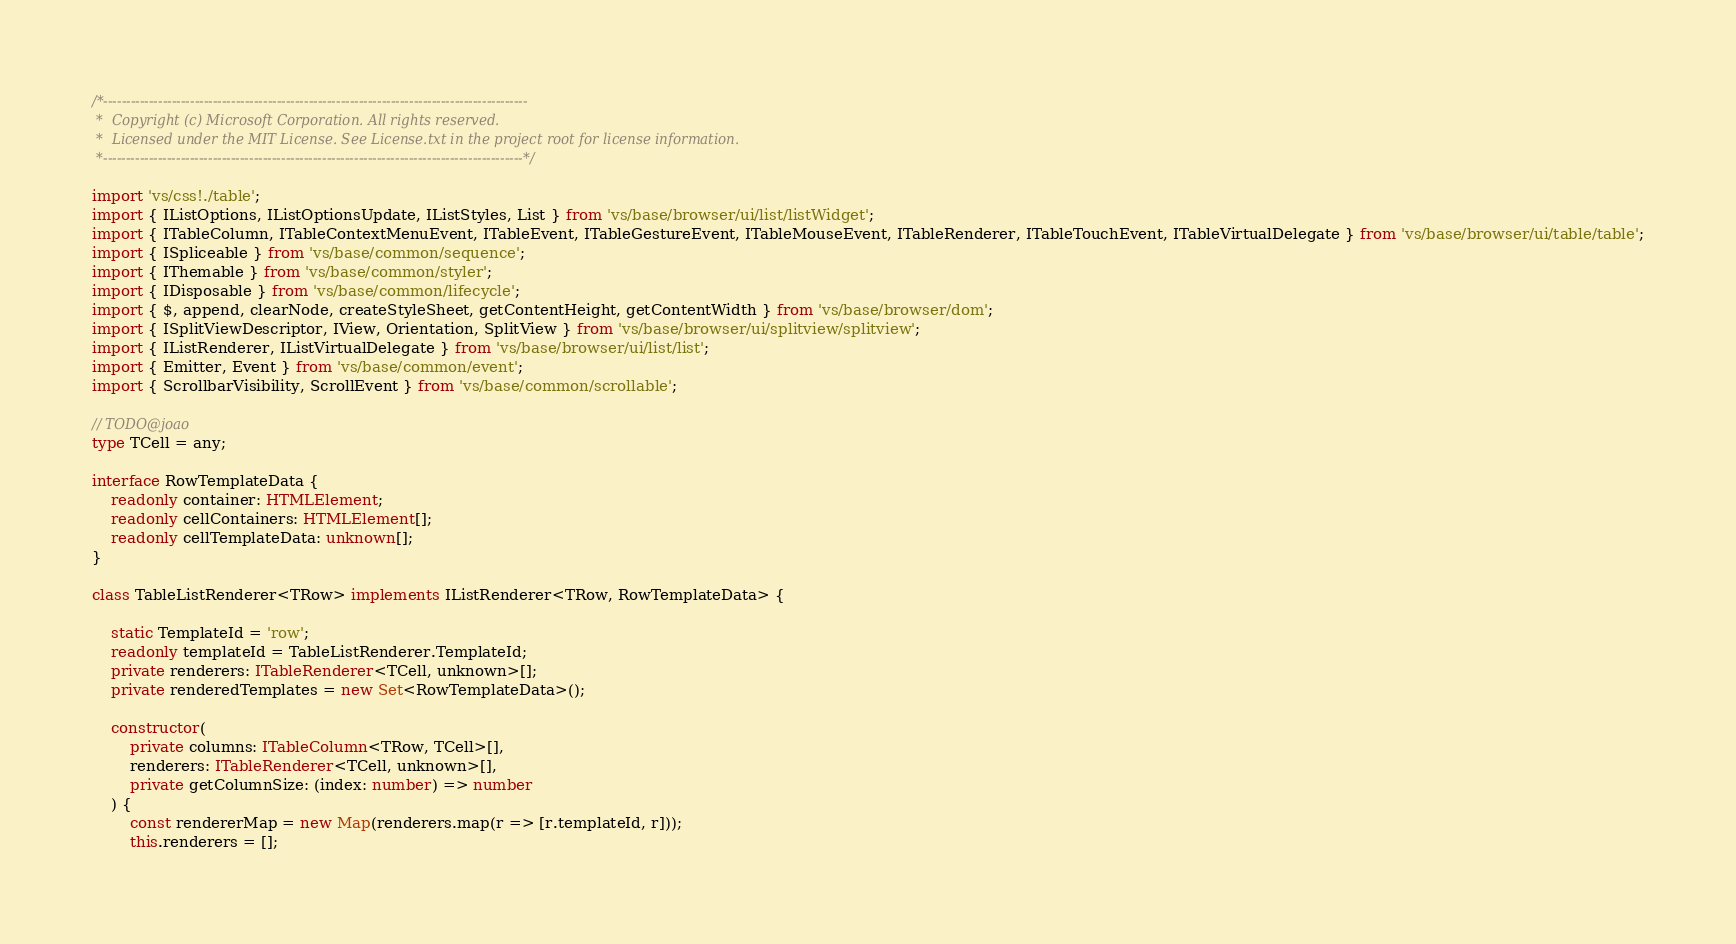<code> <loc_0><loc_0><loc_500><loc_500><_TypeScript_>/*---------------------------------------------------------------------------------------------
 *  Copyright (c) Microsoft Corporation. All rights reserved.
 *  Licensed under the MIT License. See License.txt in the project root for license information.
 *--------------------------------------------------------------------------------------------*/

import 'vs/css!./table';
import { IListOptions, IListOptionsUpdate, IListStyles, List } from 'vs/base/browser/ui/list/listWidget';
import { ITableColumn, ITableContextMenuEvent, ITableEvent, ITableGestureEvent, ITableMouseEvent, ITableRenderer, ITableTouchEvent, ITableVirtualDelegate } from 'vs/base/browser/ui/table/table';
import { ISpliceable } from 'vs/base/common/sequence';
import { IThemable } from 'vs/base/common/styler';
import { IDisposable } from 'vs/base/common/lifecycle';
import { $, append, clearNode, createStyleSheet, getContentHeight, getContentWidth } from 'vs/base/browser/dom';
import { ISplitViewDescriptor, IView, Orientation, SplitView } from 'vs/base/browser/ui/splitview/splitview';
import { IListRenderer, IListVirtualDelegate } from 'vs/base/browser/ui/list/list';
import { Emitter, Event } from 'vs/base/common/event';
import { ScrollbarVisibility, ScrollEvent } from 'vs/base/common/scrollable';

// TODO@joao
type TCell = any;

interface RowTemplateData {
	readonly container: HTMLElement;
	readonly cellContainers: HTMLElement[];
	readonly cellTemplateData: unknown[];
}

class TableListRenderer<TRow> implements IListRenderer<TRow, RowTemplateData> {

	static TemplateId = 'row';
	readonly templateId = TableListRenderer.TemplateId;
	private renderers: ITableRenderer<TCell, unknown>[];
	private renderedTemplates = new Set<RowTemplateData>();

	constructor(
		private columns: ITableColumn<TRow, TCell>[],
		renderers: ITableRenderer<TCell, unknown>[],
		private getColumnSize: (index: number) => number
	) {
		const rendererMap = new Map(renderers.map(r => [r.templateId, r]));
		this.renderers = [];
</code> 